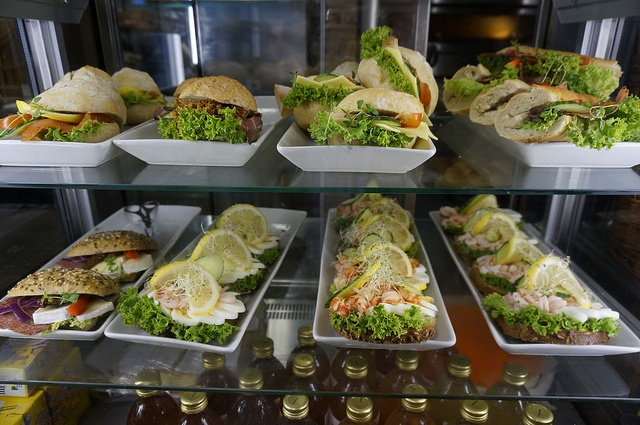Describe the objects in this image and their specific colors. I can see sandwich in black, darkgreen, lightgray, and tan tones, sandwich in black and olive tones, sandwich in black, tan, and olive tones, sandwich in black, olive, tan, and maroon tones, and sandwich in black, olive, and tan tones in this image. 